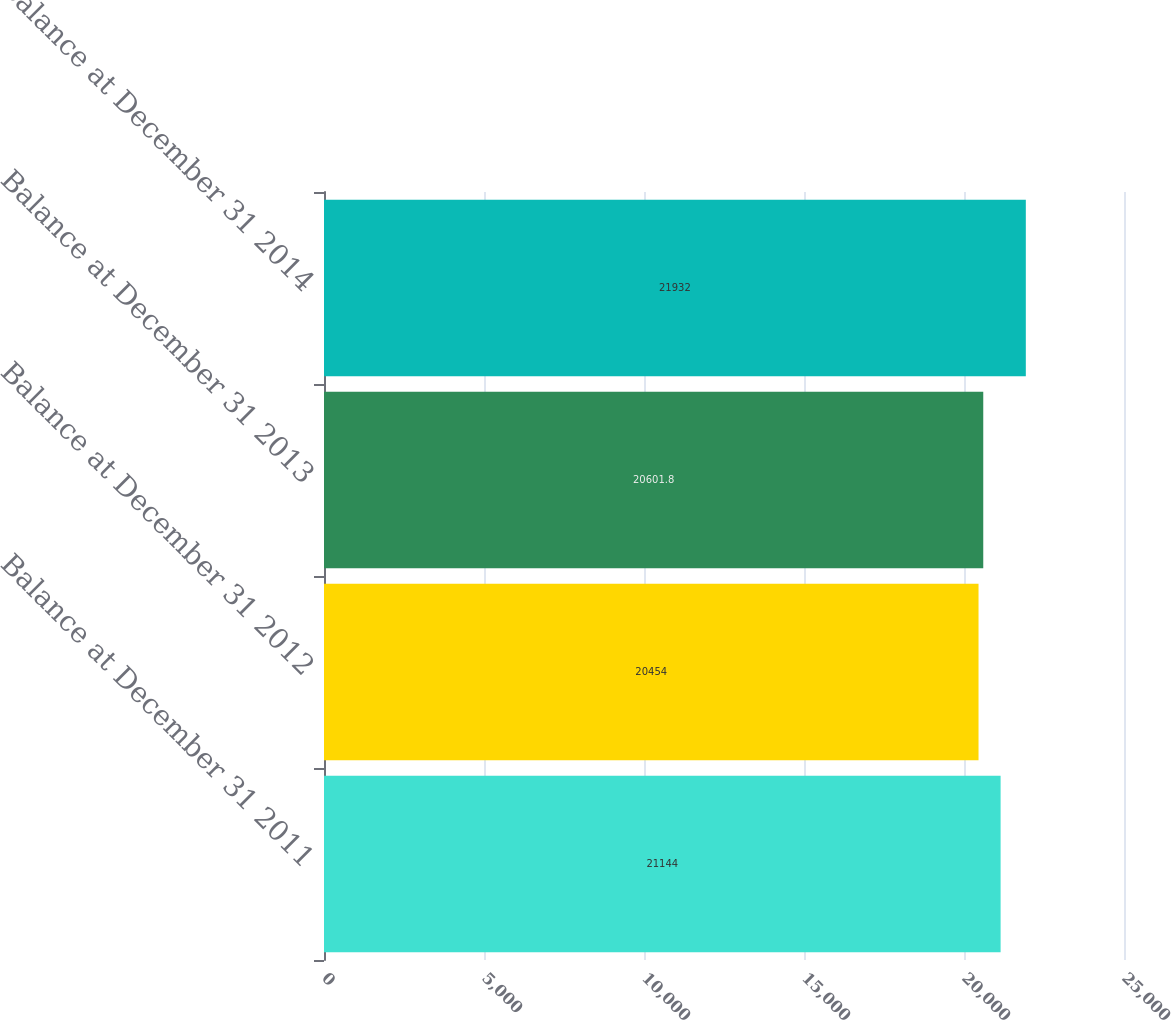Convert chart to OTSL. <chart><loc_0><loc_0><loc_500><loc_500><bar_chart><fcel>Balance at December 31 2011<fcel>Balance at December 31 2012<fcel>Balance at December 31 2013<fcel>Balance at December 31 2014<nl><fcel>21144<fcel>20454<fcel>20601.8<fcel>21932<nl></chart> 